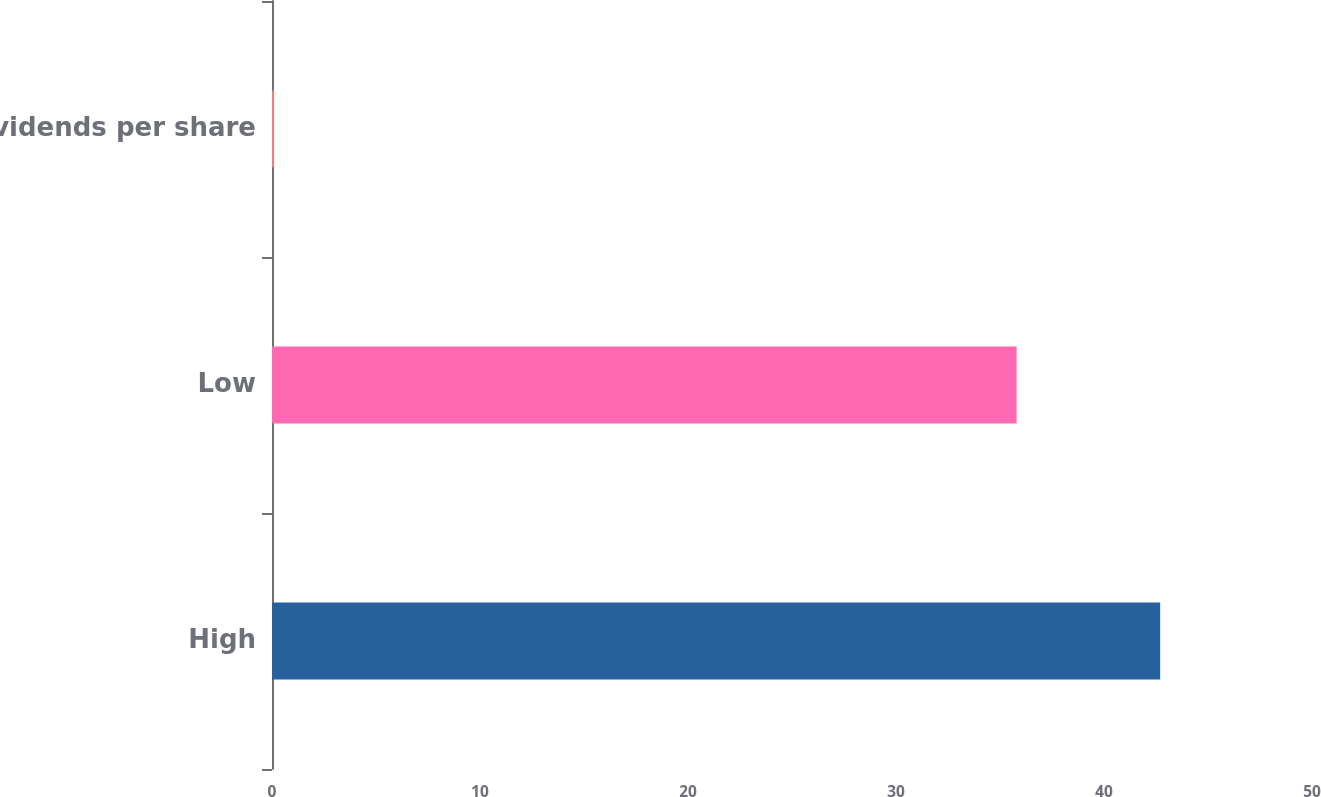Convert chart. <chart><loc_0><loc_0><loc_500><loc_500><bar_chart><fcel>High<fcel>Low<fcel>Dividends per share<nl><fcel>42.7<fcel>35.8<fcel>0.1<nl></chart> 